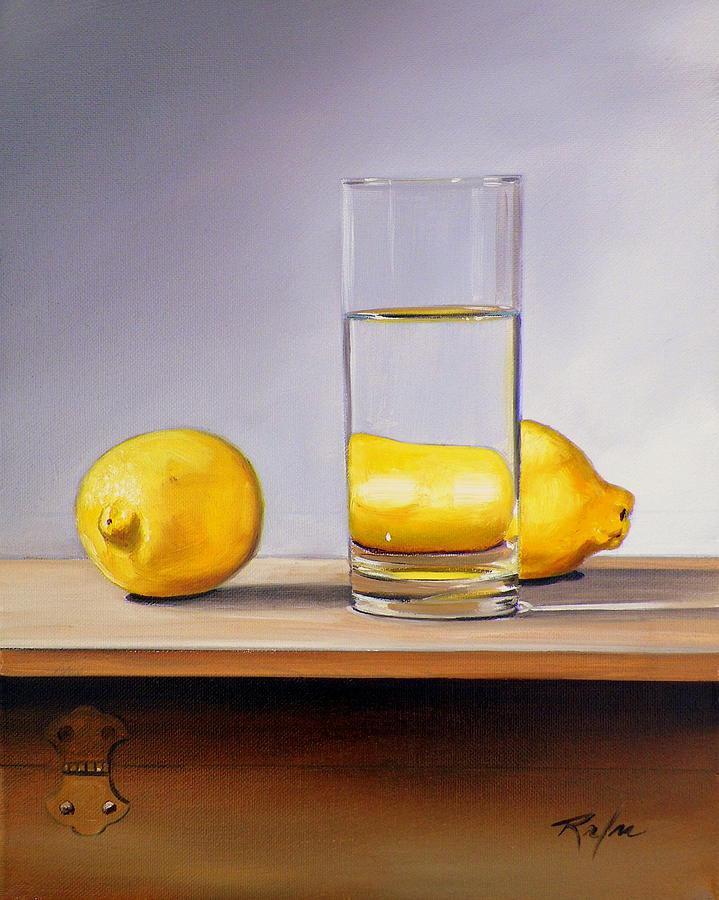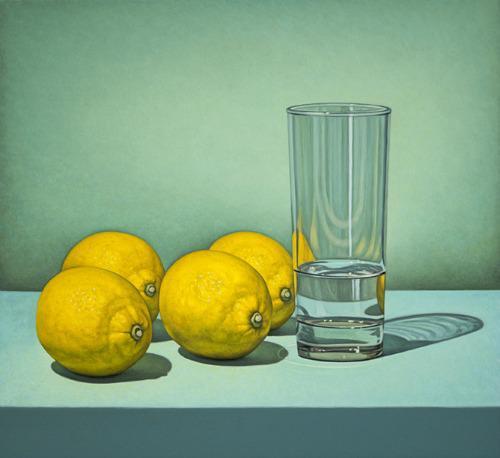The first image is the image on the left, the second image is the image on the right. Examine the images to the left and right. Is the description "At least three whole lemons are sitting near a container of water in the image on the right." accurate? Answer yes or no. Yes. The first image is the image on the left, the second image is the image on the right. Analyze the images presented: Is the assertion "The left image depicts a stemmed glass next to a whole lemon, and the right image includes a glass of clear liquid and a sliced fruit." valid? Answer yes or no. No. 